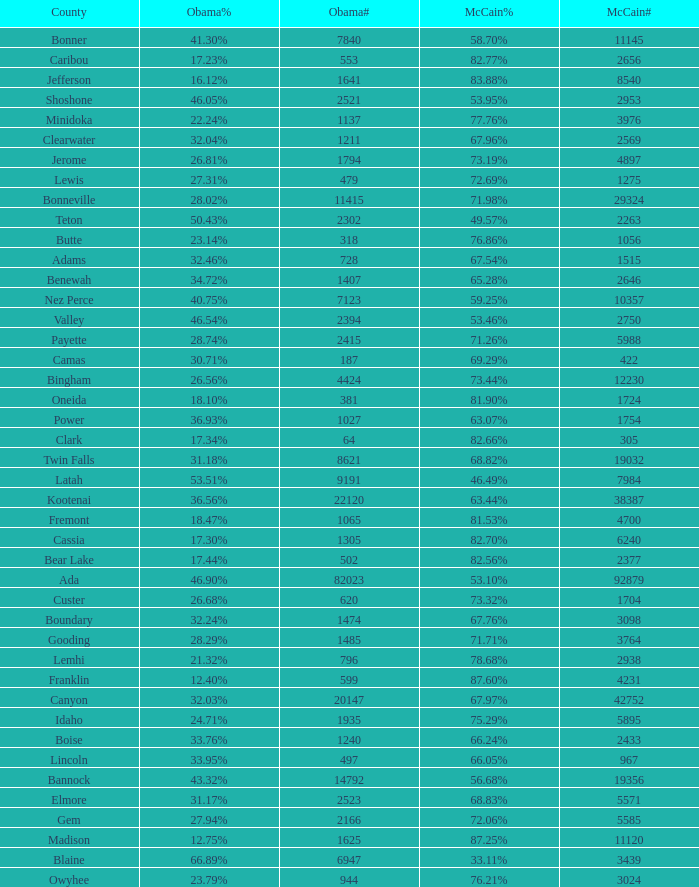What is the maximum McCain population turnout number? 92879.0. 